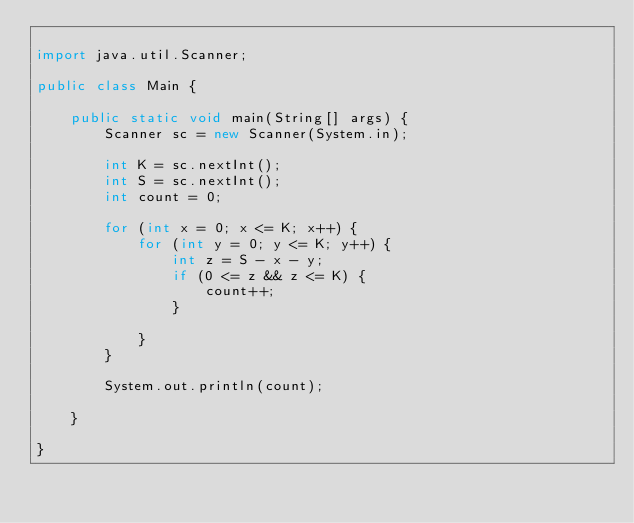<code> <loc_0><loc_0><loc_500><loc_500><_Java_>
import java.util.Scanner;

public class Main {

	public static void main(String[] args) {
		Scanner sc = new Scanner(System.in);

		int K = sc.nextInt();
		int S = sc.nextInt();
		int count = 0;

		for (int x = 0; x <= K; x++) {
			for (int y = 0; y <= K; y++) {
				int z = S - x - y;
				if (0 <= z && z <= K) {
					count++;
				}

			}
		}

		System.out.println(count);

	}

}
</code> 